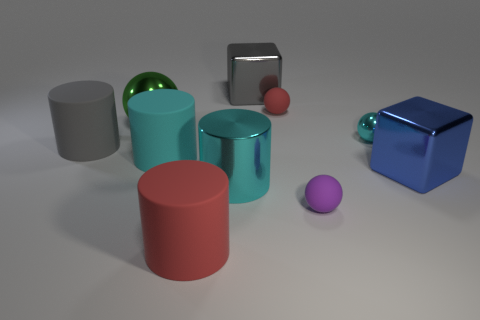How many gray shiny blocks are the same size as the gray cylinder?
Your answer should be compact. 1. There is a tiny rubber object that is in front of the gray object in front of the green shiny sphere; what color is it?
Provide a succinct answer. Purple. Are any small yellow metal things visible?
Provide a short and direct response. No. Do the large cyan matte object and the large red matte object have the same shape?
Provide a succinct answer. Yes. There is a ball that is the same color as the large metal cylinder; what is its size?
Make the answer very short. Small. There is a big metallic thing behind the tiny red matte object; what number of small cyan metal objects are right of it?
Your response must be concise. 1. What number of matte cylinders are both in front of the purple matte thing and behind the large cyan metal cylinder?
Ensure brevity in your answer.  0. What number of things are either cyan spheres or matte cylinders that are on the left side of the red rubber cylinder?
Provide a short and direct response. 3. There is another ball that is the same material as the purple sphere; what size is it?
Give a very brief answer. Small. There is a large object to the right of the rubber thing that is on the right side of the tiny red sphere; what shape is it?
Offer a very short reply. Cube. 